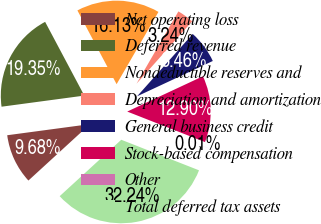Convert chart to OTSL. <chart><loc_0><loc_0><loc_500><loc_500><pie_chart><fcel>Net operating loss<fcel>Deferred revenue<fcel>Nondeductible reserves and<fcel>Depreciation and amortization<fcel>General business credit<fcel>Stock-based compensation<fcel>Other<fcel>Total deferred tax assets<nl><fcel>9.68%<fcel>19.35%<fcel>16.13%<fcel>3.24%<fcel>6.46%<fcel>12.9%<fcel>0.01%<fcel>32.24%<nl></chart> 